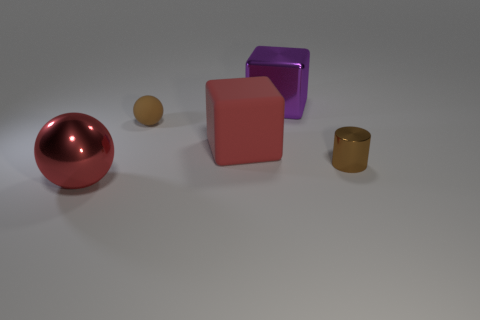Is the large metal block the same color as the big matte block?
Provide a succinct answer. No. Is the big red ball made of the same material as the tiny thing that is behind the small metallic cylinder?
Make the answer very short. No. How many things are either tiny things to the left of the cylinder or things that are in front of the large metallic block?
Your response must be concise. 4. The large metallic sphere is what color?
Your response must be concise. Red. Is the number of balls on the right side of the purple block less than the number of large red rubber things?
Your answer should be compact. Yes. Is there anything else that is the same shape as the purple metal object?
Provide a short and direct response. Yes. Are there any big purple blocks?
Your response must be concise. Yes. Is the number of small purple shiny cylinders less than the number of tiny things?
Give a very brief answer. Yes. What number of brown things have the same material as the large purple block?
Offer a terse response. 1. There is a cylinder that is the same material as the large sphere; what is its color?
Your answer should be compact. Brown. 